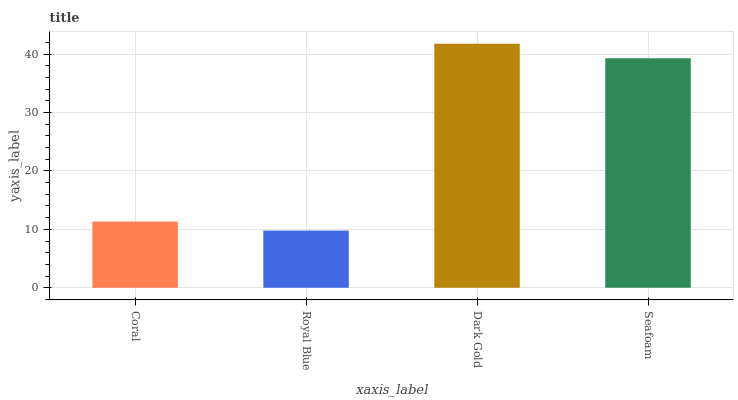Is Royal Blue the minimum?
Answer yes or no. Yes. Is Dark Gold the maximum?
Answer yes or no. Yes. Is Dark Gold the minimum?
Answer yes or no. No. Is Royal Blue the maximum?
Answer yes or no. No. Is Dark Gold greater than Royal Blue?
Answer yes or no. Yes. Is Royal Blue less than Dark Gold?
Answer yes or no. Yes. Is Royal Blue greater than Dark Gold?
Answer yes or no. No. Is Dark Gold less than Royal Blue?
Answer yes or no. No. Is Seafoam the high median?
Answer yes or no. Yes. Is Coral the low median?
Answer yes or no. Yes. Is Dark Gold the high median?
Answer yes or no. No. Is Dark Gold the low median?
Answer yes or no. No. 